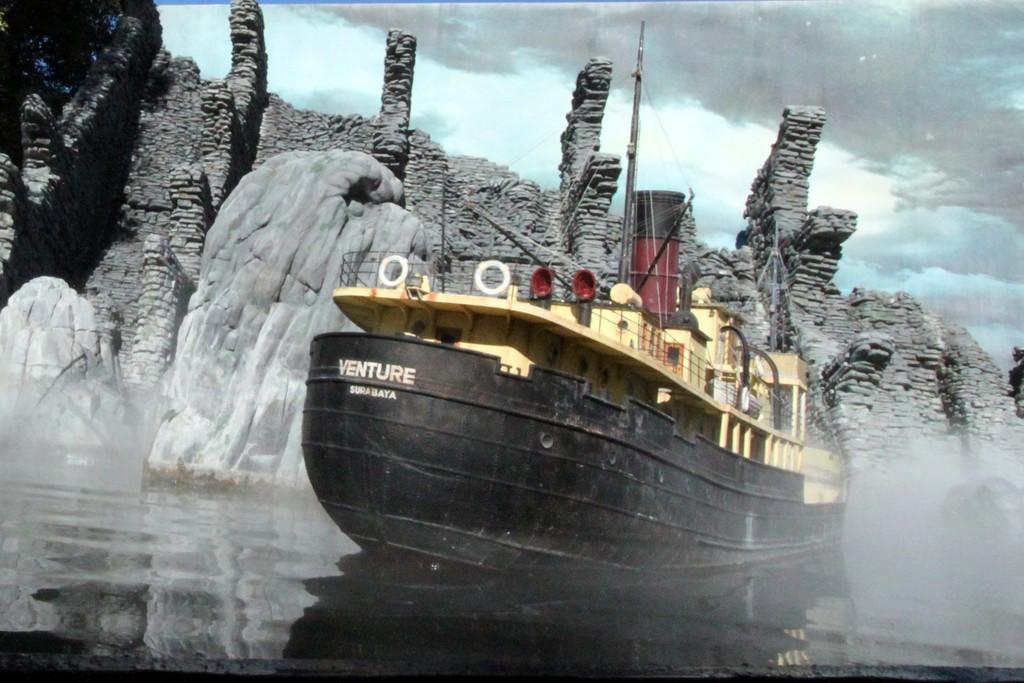Could you give a brief overview of what you see in this image? In this image we can see black color ship on the surface of water. Behind monument is there. The sky is covered with clouds. 